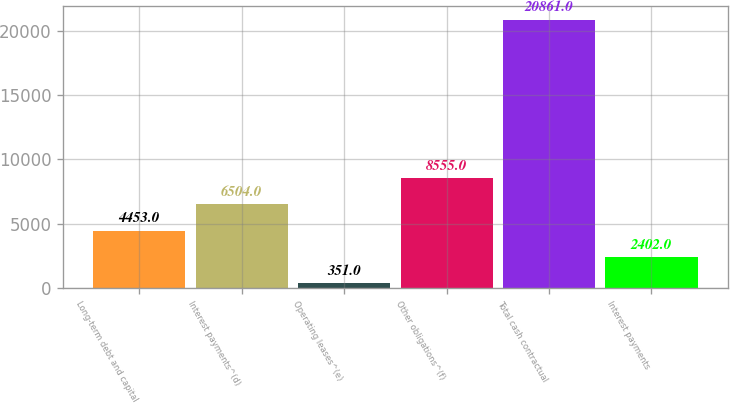Convert chart to OTSL. <chart><loc_0><loc_0><loc_500><loc_500><bar_chart><fcel>Long-term debt and capital<fcel>Interest payments^(d)<fcel>Operating leases^(e)<fcel>Other obligations^(f)<fcel>Total cash contractual<fcel>Interest payments<nl><fcel>4453<fcel>6504<fcel>351<fcel>8555<fcel>20861<fcel>2402<nl></chart> 